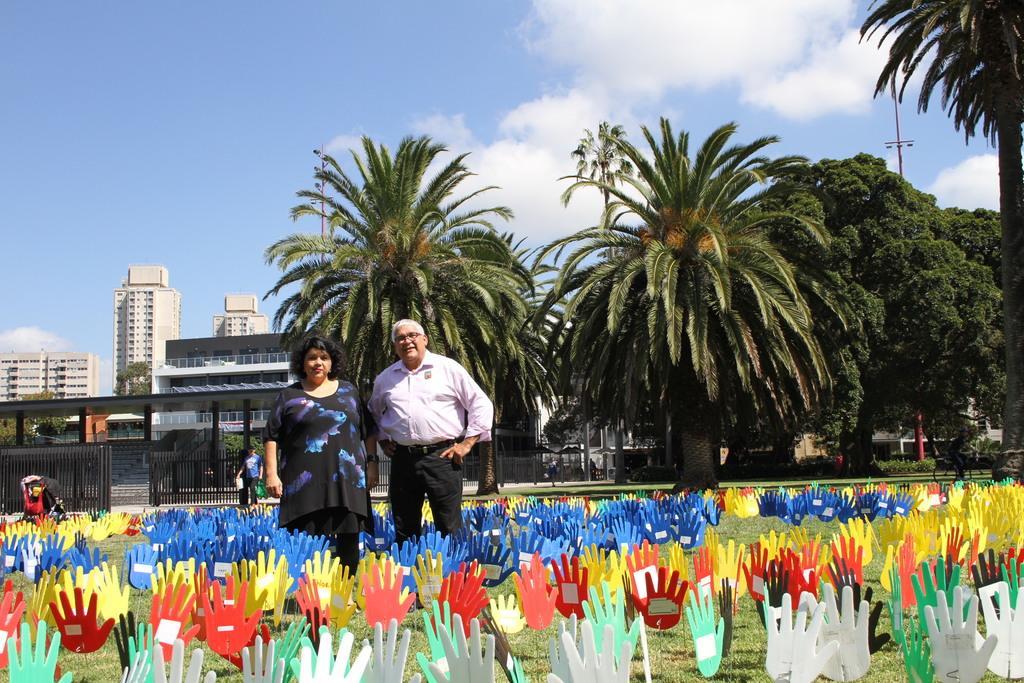Please provide a concise description of this image. There is a man and a woman standing on the grass. Here we can see boards in the shape of hands. In the background we can see buildings, trees, plants, gates, and sky with clouds. 